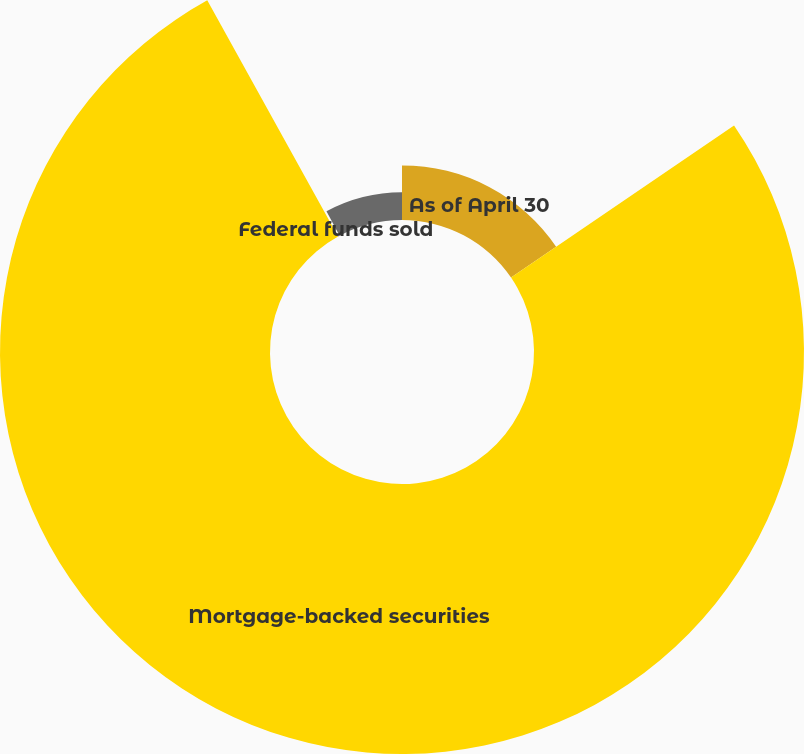<chart> <loc_0><loc_0><loc_500><loc_500><pie_chart><fcel>As of April 30<fcel>Mortgage-backed securities<fcel>Federal funds sold<fcel>FHLB stock<nl><fcel>15.47%<fcel>76.49%<fcel>0.21%<fcel>7.84%<nl></chart> 